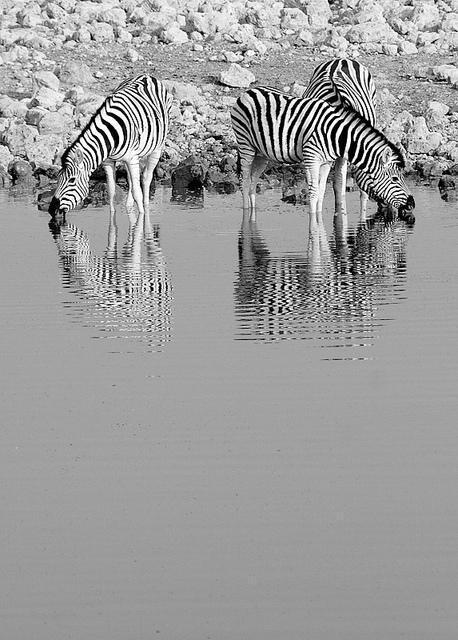How many zebras are there?
Give a very brief answer. 3. How many toothbrushes are shown?
Give a very brief answer. 0. 